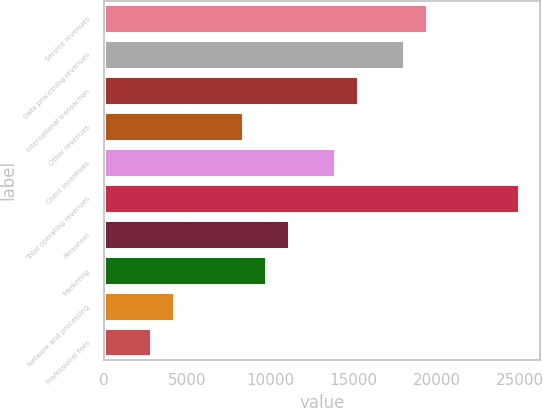Convert chart to OTSL. <chart><loc_0><loc_0><loc_500><loc_500><bar_chart><fcel>Service revenues<fcel>Data processing revenues<fcel>International transaction<fcel>Other revenues<fcel>Client incentives<fcel>Total operating revenues<fcel>Personnel<fcel>Marketing<fcel>Network and processing<fcel>Professional fees<nl><fcel>19426.4<fcel>18039.8<fcel>15266.6<fcel>8333.6<fcel>13880<fcel>24972.8<fcel>11106.8<fcel>9720.2<fcel>4173.8<fcel>2787.2<nl></chart> 